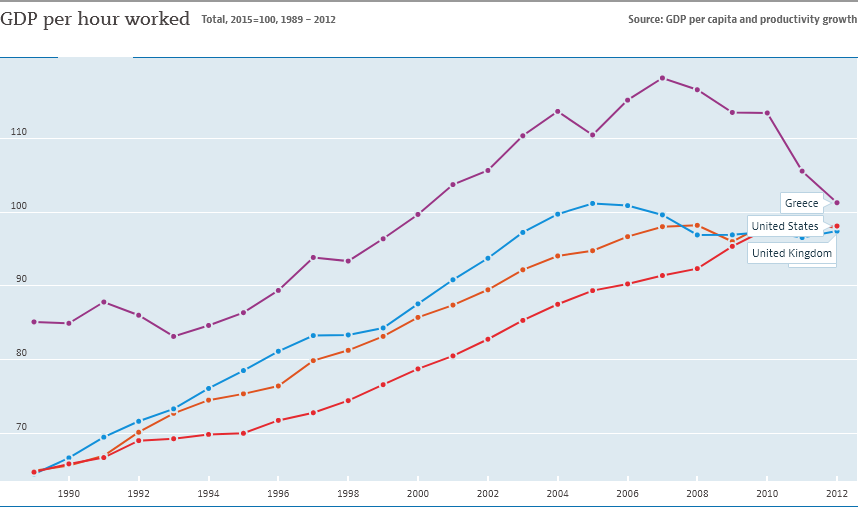Identify some key points in this picture. In the data provided, Greece's value is above 110 for 8 years. The ending year of the data is 2012. 